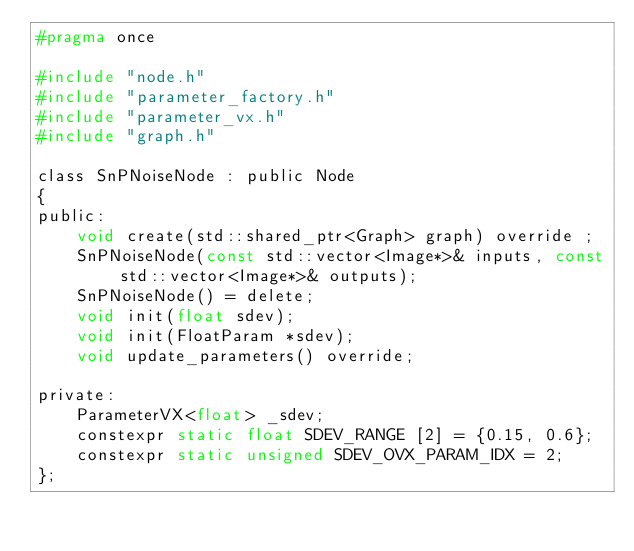<code> <loc_0><loc_0><loc_500><loc_500><_C_>#pragma once

#include "node.h"
#include "parameter_factory.h"
#include "parameter_vx.h"
#include "graph.h"

class SnPNoiseNode : public Node
{
public:
    void create(std::shared_ptr<Graph> graph) override ;
    SnPNoiseNode(const std::vector<Image*>& inputs, const std::vector<Image*>& outputs);
    SnPNoiseNode() = delete;
    void init(float sdev);
    void init(FloatParam *sdev);
    void update_parameters() override;

private:
    ParameterVX<float> _sdev;
    constexpr static float SDEV_RANGE [2] = {0.15, 0.6};
    constexpr static unsigned SDEV_OVX_PARAM_IDX = 2;
};

</code> 